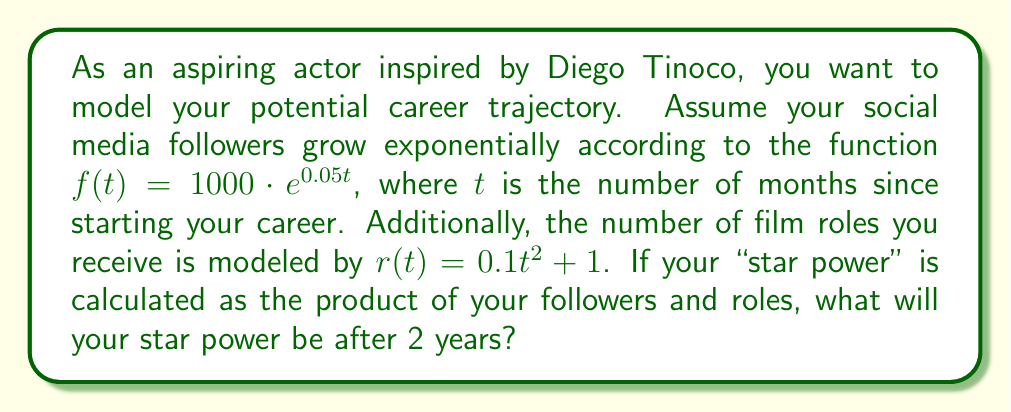Can you solve this math problem? Let's approach this step-by-step:

1) First, we need to calculate the number of followers after 2 years:
   $t = 2 \text{ years} = 24 \text{ months}$
   $f(24) = 1000 \cdot e^{0.05 \cdot 24} = 1000 \cdot e^{1.2} \approx 3320.12$

2) Next, let's calculate the number of film roles after 2 years:
   $r(24) = 0.1 \cdot 24^2 + 1 = 0.1 \cdot 576 + 1 = 58.6$

3) The star power is the product of followers and roles:
   $\text{Star Power} = f(24) \cdot r(24) \approx 3320.12 \cdot 58.6 \approx 194,559.03$

Therefore, after 2 years, your star power will be approximately 194,559.
Answer: 194,559 